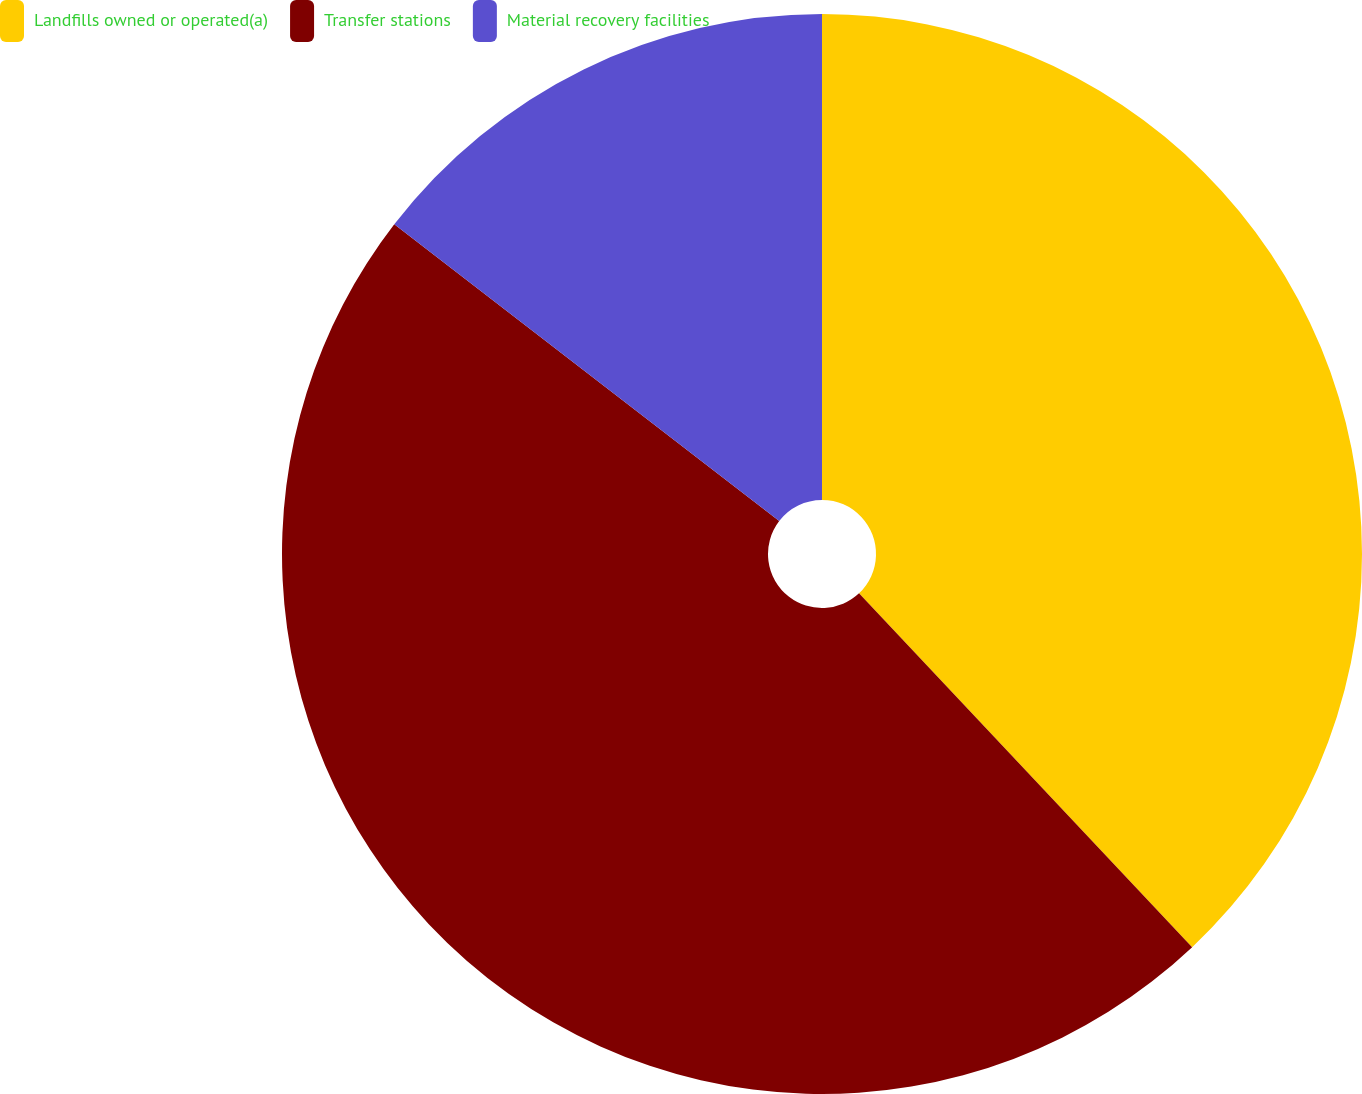Convert chart to OTSL. <chart><loc_0><loc_0><loc_500><loc_500><pie_chart><fcel>Landfills owned or operated(a)<fcel>Transfer stations<fcel>Material recovery facilities<nl><fcel>37.98%<fcel>47.47%<fcel>14.55%<nl></chart> 